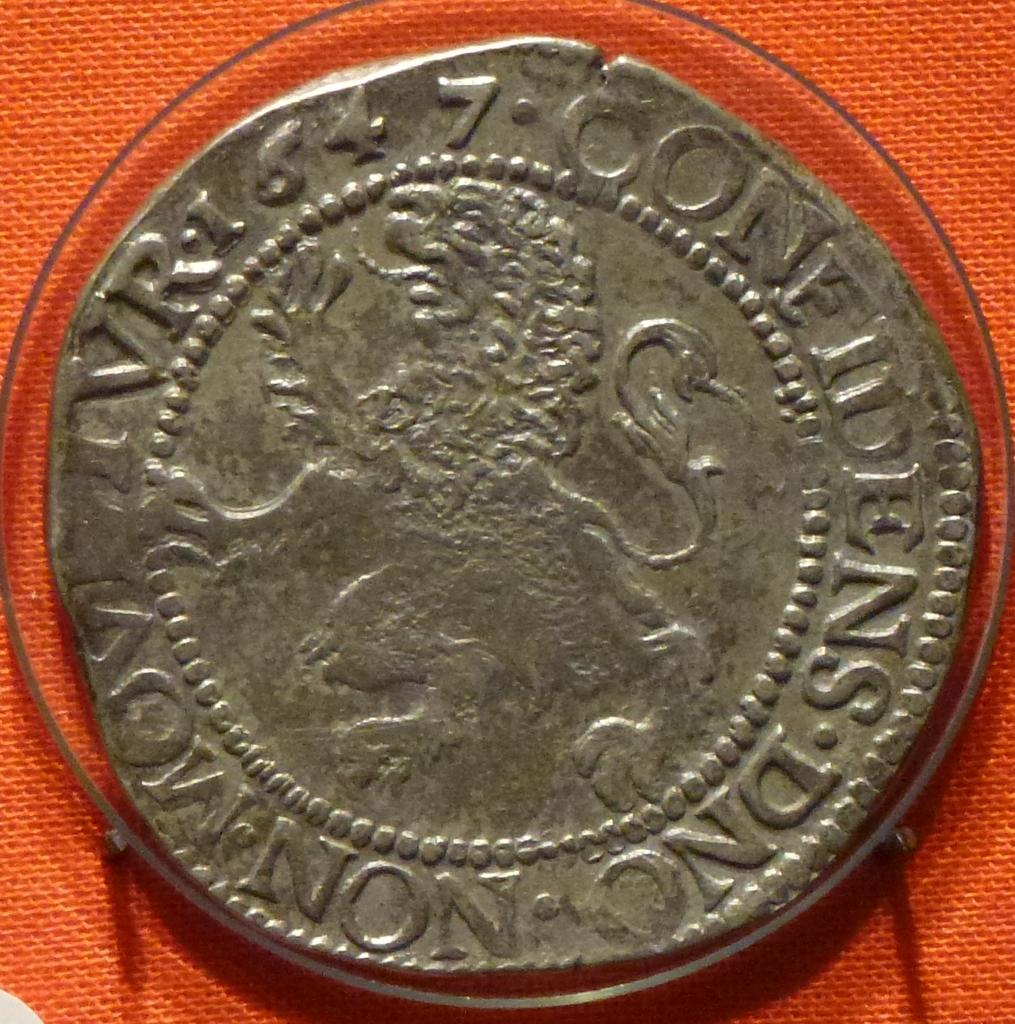<image>
Give a short and clear explanation of the subsequent image. A silver coin with the number seven written on it. 